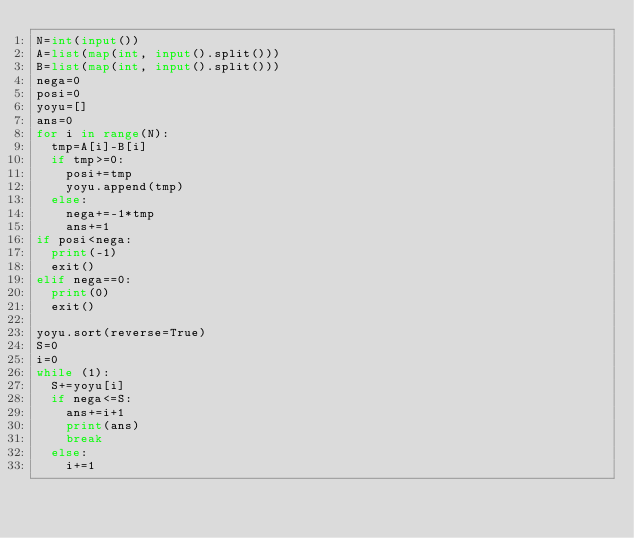Convert code to text. <code><loc_0><loc_0><loc_500><loc_500><_Python_>N=int(input())
A=list(map(int, input().split()))
B=list(map(int, input().split()))
nega=0
posi=0
yoyu=[]
ans=0
for i in range(N):
  tmp=A[i]-B[i]
  if tmp>=0:
    posi+=tmp
    yoyu.append(tmp)
  else:
    nega+=-1*tmp
    ans+=1
if posi<nega:
  print(-1)
  exit()
elif nega==0:
  print(0)
  exit()

yoyu.sort(reverse=True)
S=0
i=0
while (1):
  S+=yoyu[i]
  if nega<=S:
    ans+=i+1
    print(ans)
    break
  else:
    i+=1</code> 